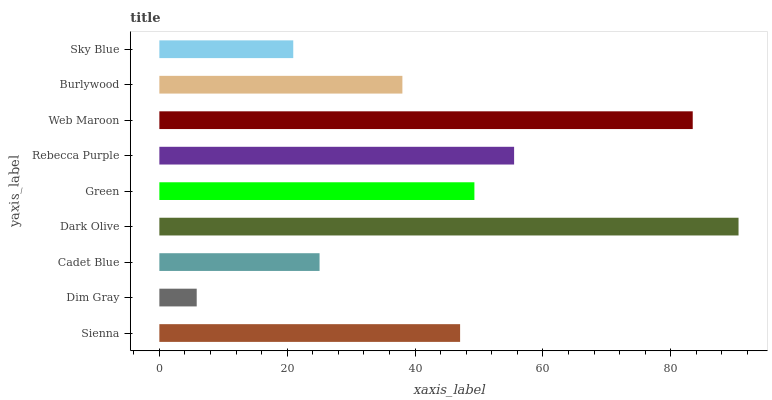Is Dim Gray the minimum?
Answer yes or no. Yes. Is Dark Olive the maximum?
Answer yes or no. Yes. Is Cadet Blue the minimum?
Answer yes or no. No. Is Cadet Blue the maximum?
Answer yes or no. No. Is Cadet Blue greater than Dim Gray?
Answer yes or no. Yes. Is Dim Gray less than Cadet Blue?
Answer yes or no. Yes. Is Dim Gray greater than Cadet Blue?
Answer yes or no. No. Is Cadet Blue less than Dim Gray?
Answer yes or no. No. Is Sienna the high median?
Answer yes or no. Yes. Is Sienna the low median?
Answer yes or no. Yes. Is Web Maroon the high median?
Answer yes or no. No. Is Dim Gray the low median?
Answer yes or no. No. 